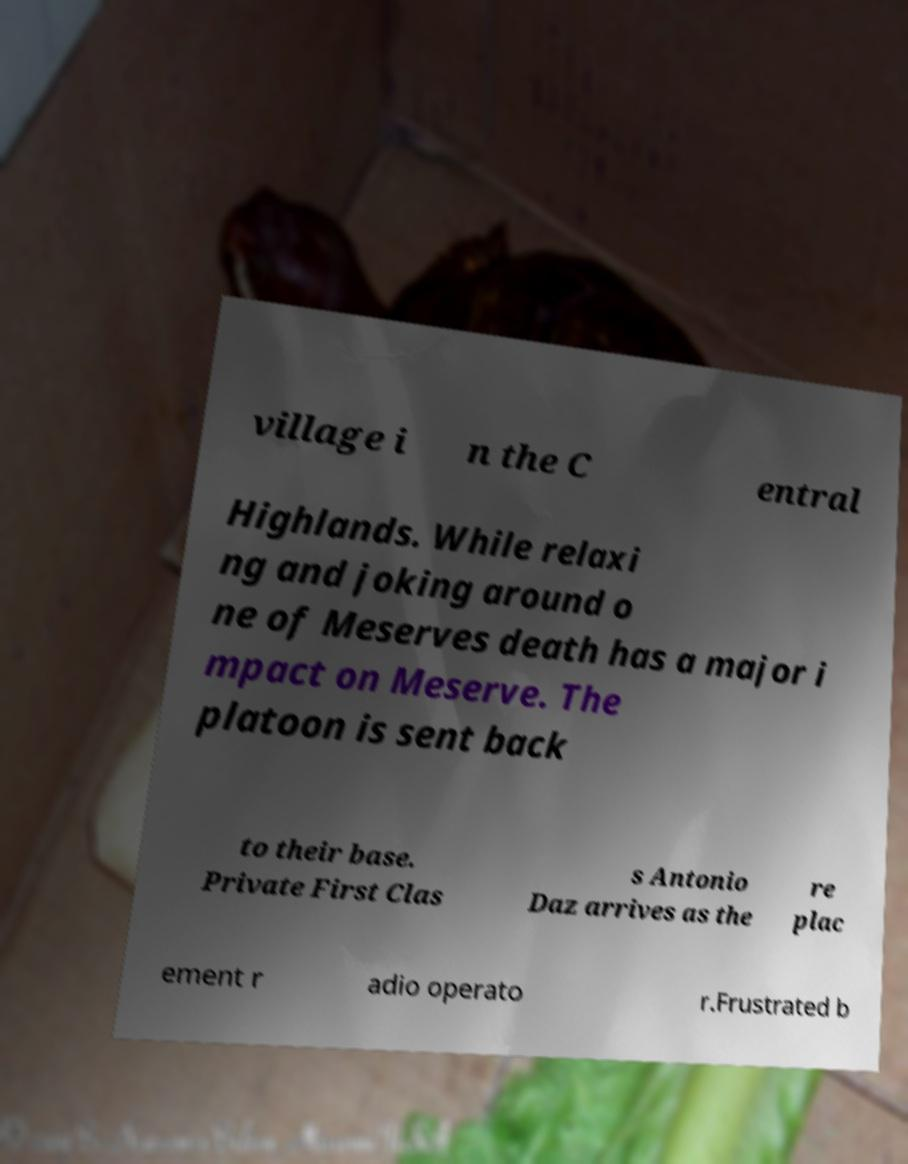Can you accurately transcribe the text from the provided image for me? village i n the C entral Highlands. While relaxi ng and joking around o ne of Meserves death has a major i mpact on Meserve. The platoon is sent back to their base. Private First Clas s Antonio Daz arrives as the re plac ement r adio operato r.Frustrated b 